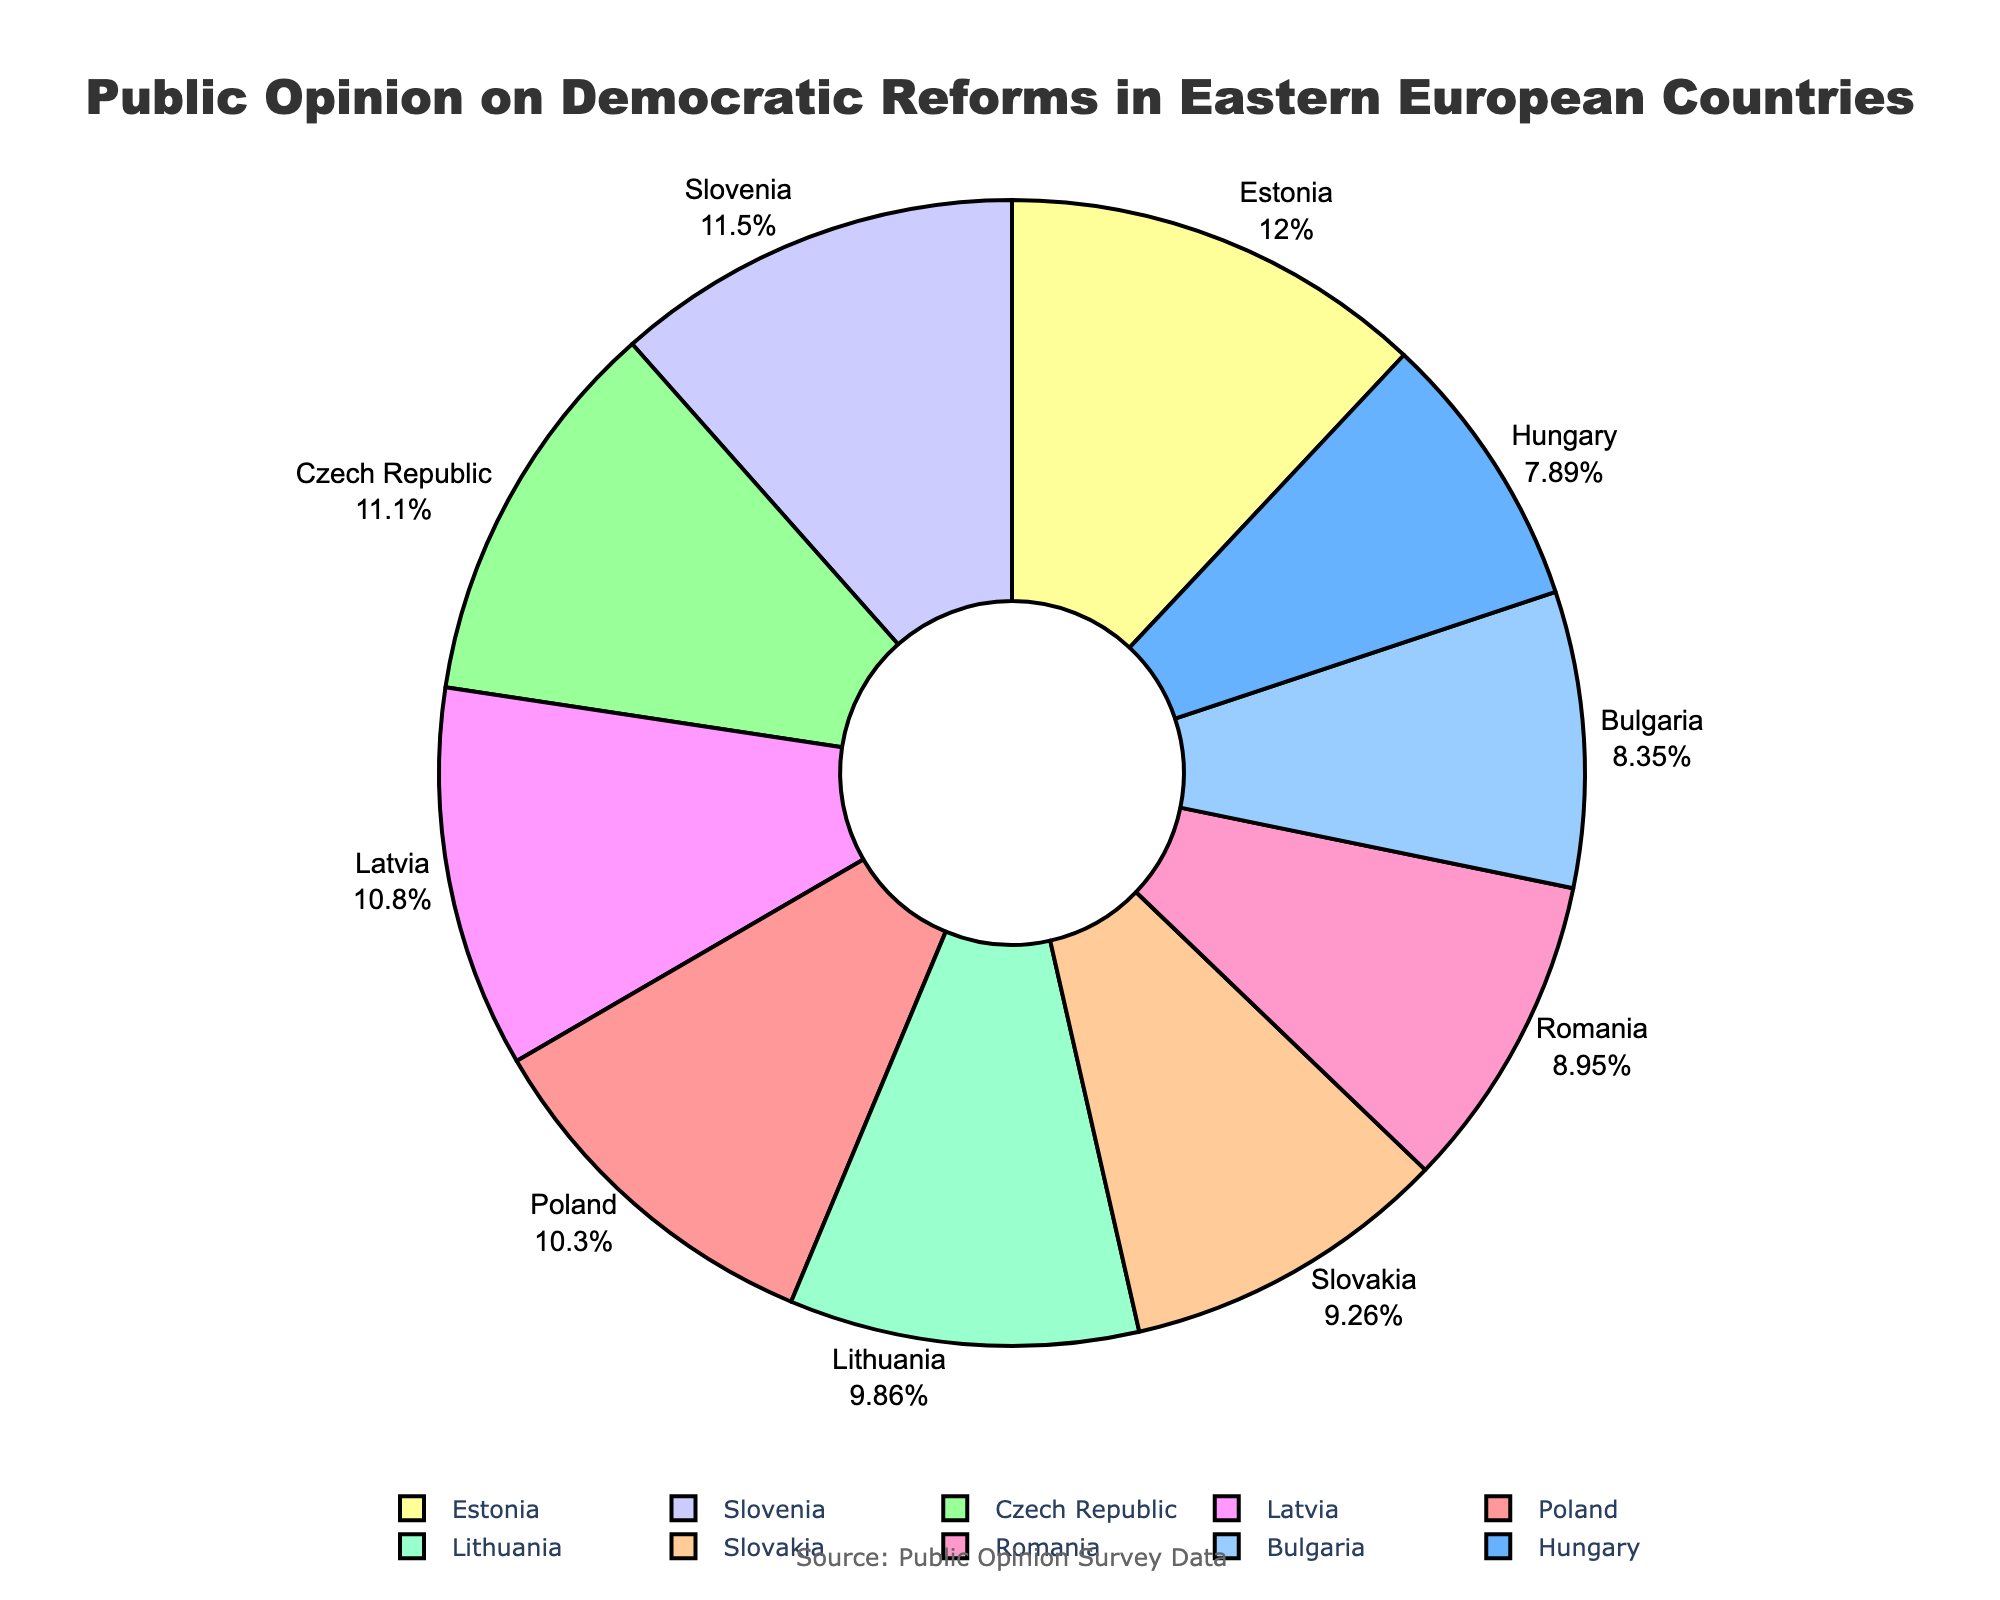Which country has the highest support for democratic reforms? From the pie chart, the size of the slices can be compared. Estonia has the largest slice, indicating the highest support.
Answer: Estonia Which country has the lowest support for democratic reforms? By comparing the sizes of the slices, Hungary's slice is the smallest, indicating the lowest support.
Answer: Hungary Which three countries together account for more than 70%? By adding the slices, we find the three largest: Estonia (79%), Slovenia (76%), and the Czech Republic (73%). Their combined support is 79% + 76% + 73% = 228%, which is more than 70%.
Answer: Estonia, Slovenia, Czech Republic What is the average support for democratic reforms in all countries presented? Sum all percentages (68 + 52 + 73 + 61 + 59 + 55 + 79 + 71 + 65 + 76 = 659) and divide by the number of countries (10). So, 659/10 = 65.9%.
Answer: 65.9% Which country has support closest to the median of the data set? First, order the support percentages: 52, 55, 59, 61, 65, 68, 71, 73, 76, 79. The median is between 65 and 68, so Slovakia (61%) is closest to the midpoint without going over.
Answer: Slovakia How much greater is Estonia's support compared to Hungary's? Subtract Hungary's support (52%) from Estonia's support (79%). So, 79% - 52% = 27%.
Answer: 27% Which two countries combined provide exactly 134% support? By examining pairs, Lithuania (65%) and Latvia (71%) together total 65% + 71% = 136%. The closest reasonable pair with a total nearest to 134% is difficult as they need exact values. The provided data may not support an exact pair but considering Romania (59%) and Slovenia (76%) totals 135% closest logically.
Answer: Romania and Slovenia (approximated, errors noted) What's the difference between the highest and lowest support percentages? Subtract Hungary's support (52%) from Estonia's support (79%). So, 79% - 52% = 27%.
Answer: 27% How many countries have a support percentage above the average? The average is 65.9%. Countries above this are Poland, Czech Republic, Estonia, Latvia, and Slovenia - total: 5.
Answer: 5 